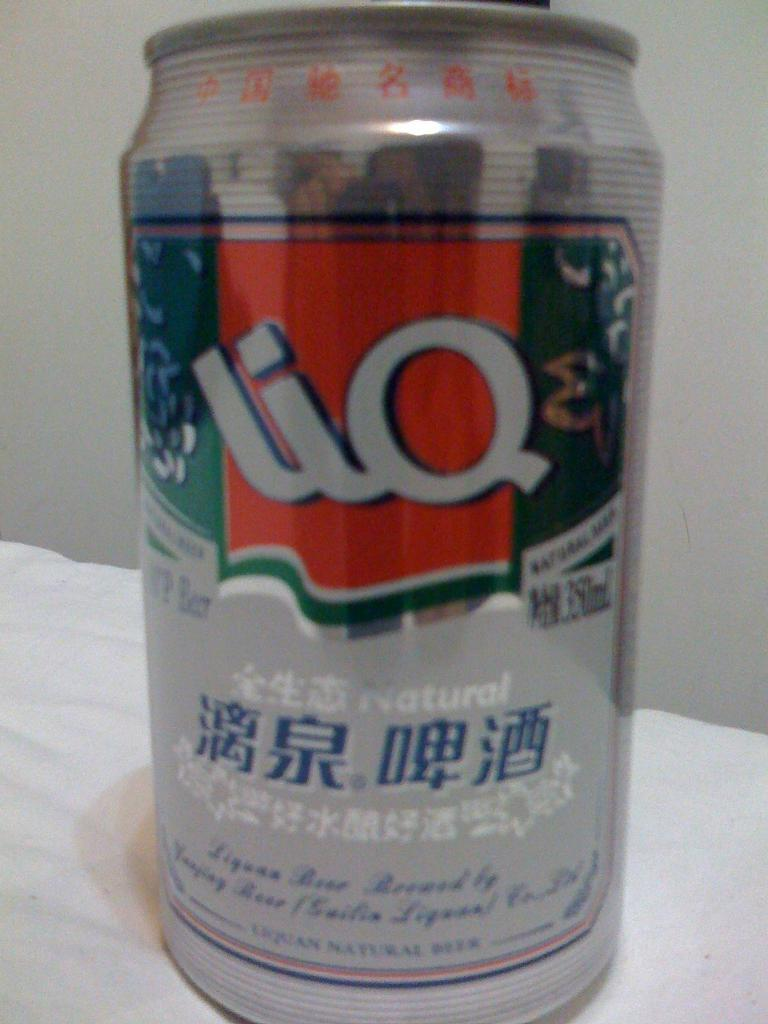<image>
Create a compact narrative representing the image presented. Small silver beer can that says LIQ on it. 